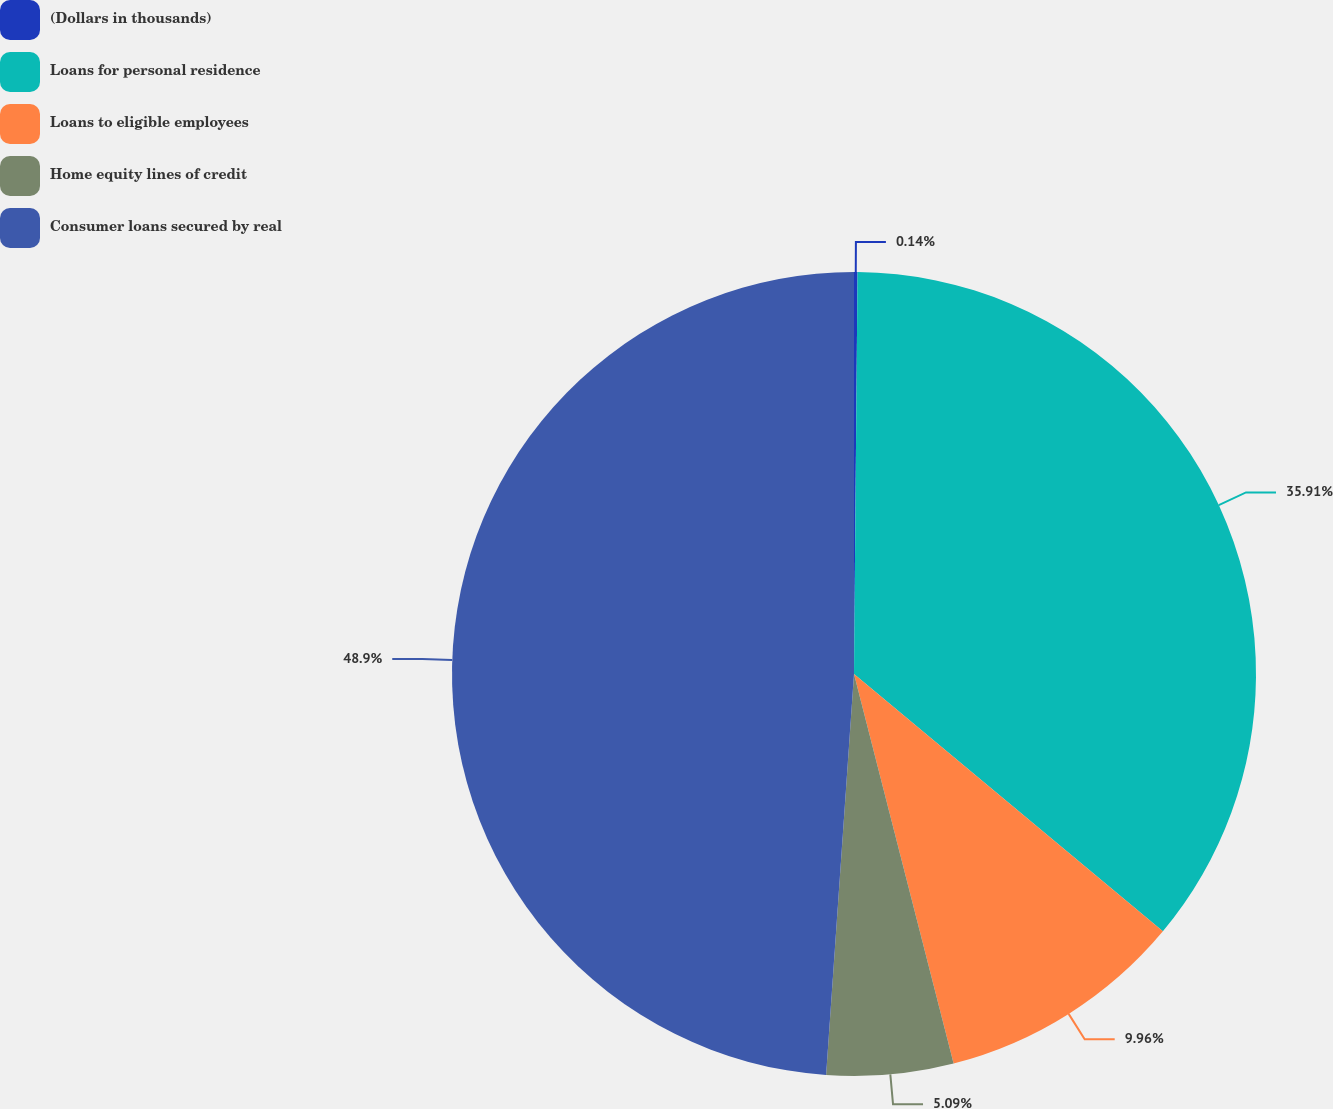Convert chart to OTSL. <chart><loc_0><loc_0><loc_500><loc_500><pie_chart><fcel>(Dollars in thousands)<fcel>Loans for personal residence<fcel>Loans to eligible employees<fcel>Home equity lines of credit<fcel>Consumer loans secured by real<nl><fcel>0.14%<fcel>35.91%<fcel>9.96%<fcel>5.09%<fcel>48.89%<nl></chart> 